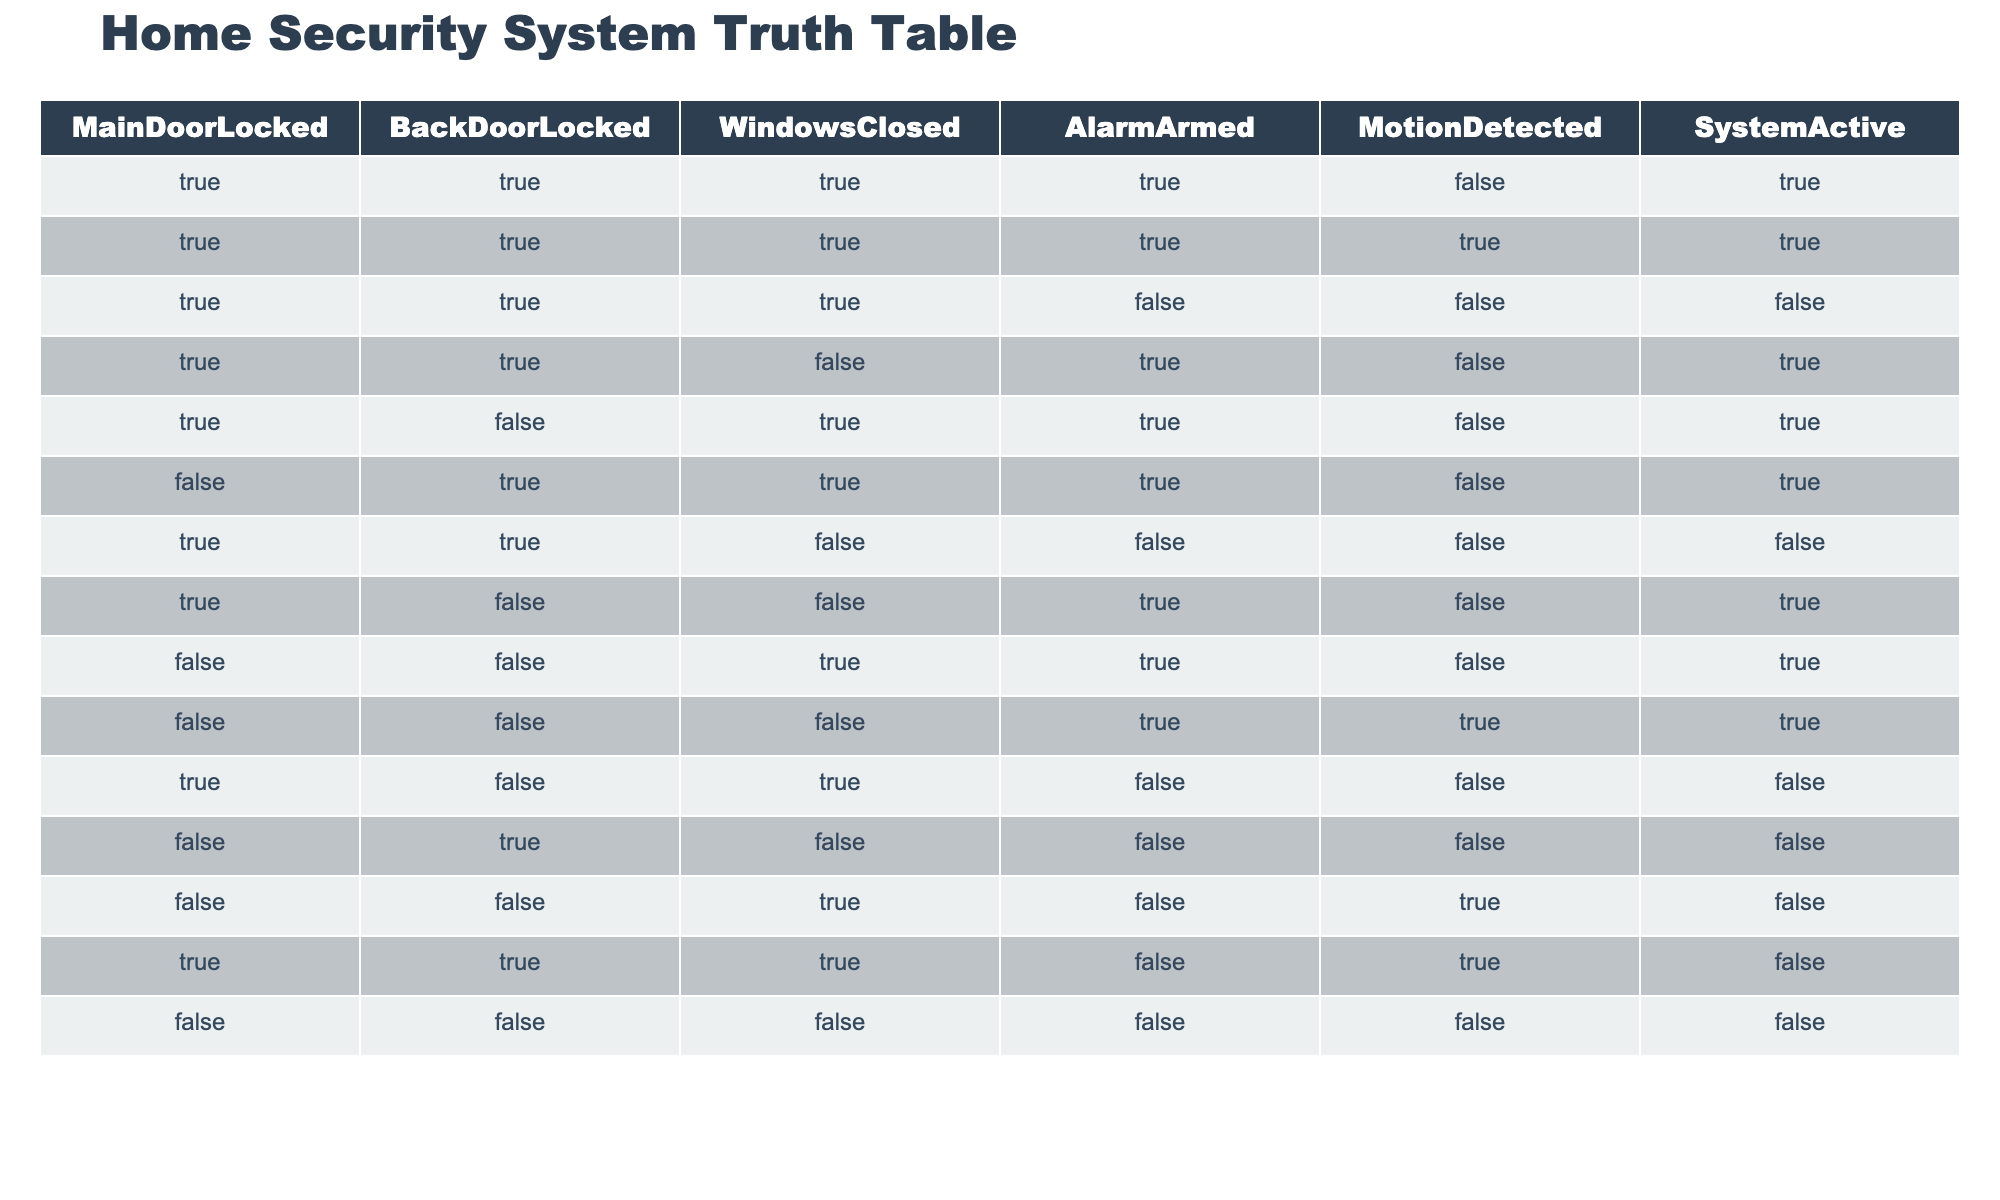What is the value of 'AlarmArmed' when 'MainDoorLocked' is TRUE and 'WindowsClosed' is TRUE? By looking at the table, we can find all instances where 'MainDoorLocked' is TRUE and 'WindowsClosed' is TRUE. There are two such rows: the first row (AlarmArmed=true) and the second row (AlarmArmed=false). Therefore, the values of 'AlarmArmed' are TRUE and FALSE.
Answer: TRUE and FALSE How many rows have 'SystemActive' set to TRUE? To find this value, count the rows in the table where 'SystemActive' is TRUE. There are 6 entries with 'SystemActive' as TRUE (rows 1, 2, 4, 5, 6, and 9).
Answer: 6 Is 'MotionDetected' ever TRUE when 'AlarmArmed' is TRUE? We can check all instances in the table where 'AlarmArmed' is TRUE and observe the value of 'MotionDetected'. The table indicates that 'MotionDetected' is FALSE in the first row and TRUE in the last row. Therefore, the answer is YES, as we have at least one instance where it is TRUE.
Answer: Yes What is the average number of doors locked for the rows where 'AlarmArmed' is FALSE? First, identify the rows where 'AlarmArmed' is FALSE, which are rows 3, 7, 10, 11, 12, 13, and 14. In total, there are 7 such rows. Count the number of locked doors by observing the values of 'MainDoorLocked' and 'BackDoorLocked'. If we calculate the total locked doors across these rows (adding each instance of TRUE as 1), we find 9 total locked doors across these 7 rows. The average is then 9 divided by 7, which is approximately 1.29.
Answer: Approximately 1.29 How many instances are there where 'MainDoorLocked' is FALSE and 'SystemActive' is TRUE? Look for rows where 'MainDoorLocked' is FALSE and check if 'SystemActive' is TRUE. In total, there are 3 rows that meet this criterion (rows 6, 10, and 12).
Answer: 3 